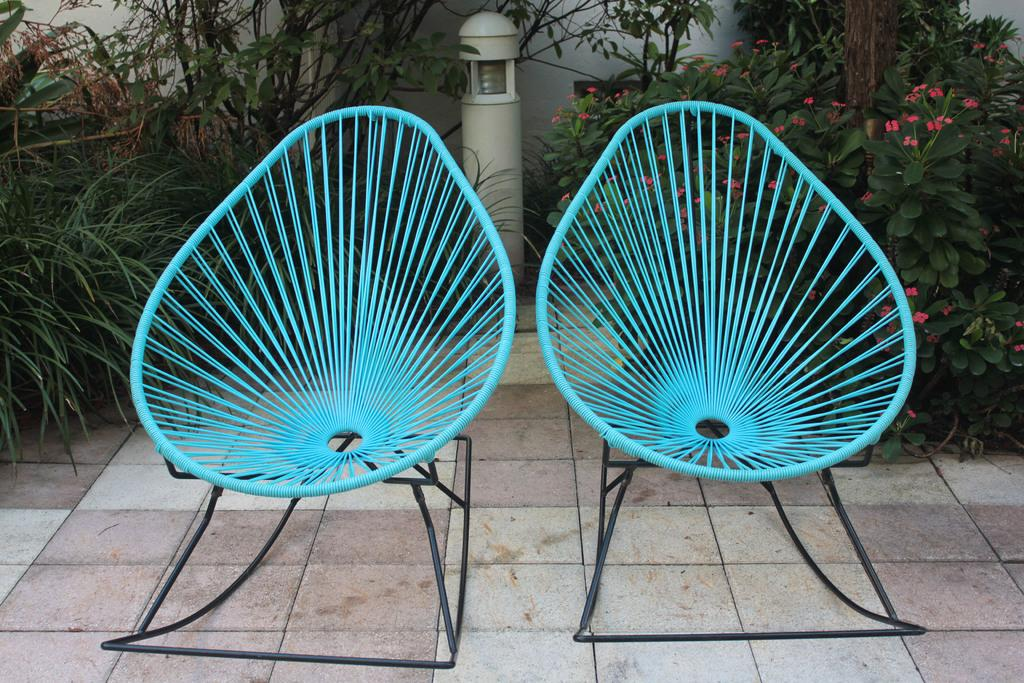What type of furniture is located in the middle of the image? There are two chairs in the middle of the image. What can be seen in the background of the image? There are plants in the background of the image. What is the source of light visible at the top of the image? There is a light visible at the top of the image. How many facts are mentioned in the image? There are no facts mentioned in the image; the provided facts are separate from the image itself. What type of bean is present in the image? There is no bean present in the image. 